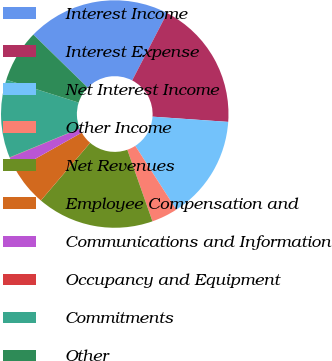Convert chart to OTSL. <chart><loc_0><loc_0><loc_500><loc_500><pie_chart><fcel>Interest Income<fcel>Interest Expense<fcel>Net Interest Income<fcel>Other Income<fcel>Net Revenues<fcel>Employee Compensation and<fcel>Communications and Information<fcel>Occupancy and Equipment<fcel>Commitments<fcel>Other<nl><fcel>20.32%<fcel>18.48%<fcel>14.79%<fcel>3.73%<fcel>16.63%<fcel>5.58%<fcel>1.89%<fcel>0.05%<fcel>11.11%<fcel>7.42%<nl></chart> 